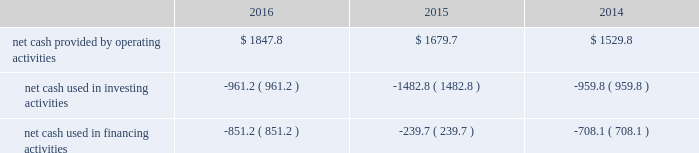Liquidity and capital resources the major components of changes in cash flows for 2016 , 2015 and 2014 are discussed in the following paragraphs .
The table summarizes our cash flow from operating activities , investing activities and financing activities for the years ended december 31 , 2016 , 2015 and 2014 ( in millions of dollars ) : .
Cash flows provided by operating activities the most significant items affecting the comparison of our operating cash flows for 2016 and 2015 are summarized below : changes in assets and liabilities , net of effects from business acquisitions and divestitures , decreased our cash flow from operations by $ 205.2 million in 2016 , compared to a decrease of $ 316.7 million in 2015 , primarily as a result of the following : 2022 our accounts receivable , exclusive of the change in allowance for doubtful accounts and customer credits , increased $ 52.3 million during 2016 due to the timing of billings net of collections , compared to a $ 15.7 million increase in 2015 .
As of december 31 , 2016 and 2015 , our days sales outstanding were 38.1 and 38.3 days , or 26.1 and 25.8 days net of deferred revenue , respectively .
2022 our accounts payable decreased $ 9.8 million during 2016 compared to an increase of $ 35.6 million during 2015 , due to the timing of payments .
2022 cash paid for capping , closure and post-closure obligations was $ 11.0 million lower during 2016 compared to 2015 .
The decrease in cash paid for capping , closure , and post-closure obligations is primarily due to payments in 2015 related to a required capping event at one of our closed landfills .
2022 cash paid for remediation obligations was $ 13.2 million lower during 2016 compared to 2015 primarily due to the timing of obligations .
In addition , cash paid for income taxes was approximately $ 265 million and $ 321 million for 2016 and 2015 , respectively .
Income taxes paid in 2016 and 2015 reflect the favorable tax depreciation provisions of the protecting americans from tax hikes act signed into law in december 2015 as well as the realization of certain tax credits .
Cash paid for interest was $ 330.2 million and $ 327.6 million for 2016 and 2015 , respectively .
The most significant items affecting the comparison of our operating cash flows for 2015 and 2014 are summarized below : changes in assets and liabilities , net of effects of business acquisitions and divestitures , decreased our cash flow from operations by $ 316.7 million in 2015 , compared to a decrease of $ 295.6 million in 2014 , primarily as a result of the following : 2022 our accounts receivable , exclusive of the change in allowance for doubtful accounts and customer credits , increased $ 15.7 million during 2015 due to the timing of billings , net of collections , compared to a $ 54.3 million increase in 2014 .
As of december 31 , 2015 and 2014 , our days sales outstanding were 38 days , or 26 and 25 days net of deferred revenue , respectively .
2022 our accounts payable increased $ 35.6 million and $ 3.3 million during 2015 and 2014 , respectively , due to the timing of payments as of december 31 , 2015. .
What was the ratio of the changes in assets and liabilities , net of effects from business acquisitions and divestitures in 2016 to 2015? 
Rationale: for every dollar in 2015 of changes in assets and liabilities , net of effects from business acquisitions and divestitures there was $ 0.67 in 2016
Computations: (205.2 / 316.7)
Answer: 0.64793. 